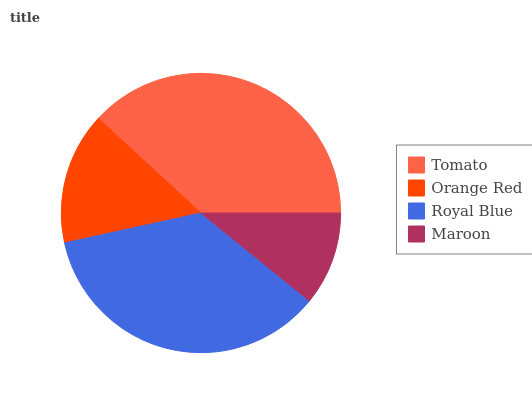Is Maroon the minimum?
Answer yes or no. Yes. Is Tomato the maximum?
Answer yes or no. Yes. Is Orange Red the minimum?
Answer yes or no. No. Is Orange Red the maximum?
Answer yes or no. No. Is Tomato greater than Orange Red?
Answer yes or no. Yes. Is Orange Red less than Tomato?
Answer yes or no. Yes. Is Orange Red greater than Tomato?
Answer yes or no. No. Is Tomato less than Orange Red?
Answer yes or no. No. Is Royal Blue the high median?
Answer yes or no. Yes. Is Orange Red the low median?
Answer yes or no. Yes. Is Tomato the high median?
Answer yes or no. No. Is Maroon the low median?
Answer yes or no. No. 